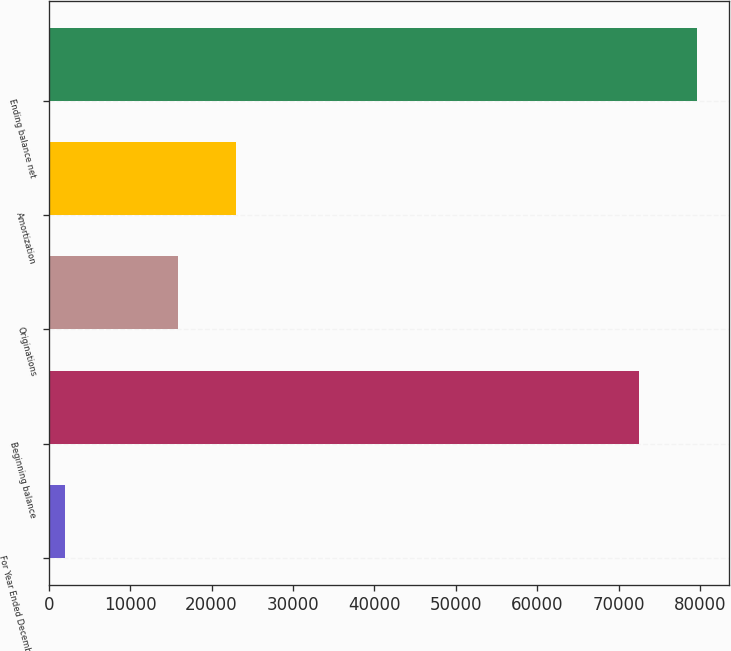<chart> <loc_0><loc_0><loc_500><loc_500><bar_chart><fcel>For Year Ended December 31<fcel>Beginning balance<fcel>Originations<fcel>Amortization<fcel>Ending balance net<nl><fcel>2014<fcel>72499<fcel>15922<fcel>23014.5<fcel>79591.5<nl></chart> 